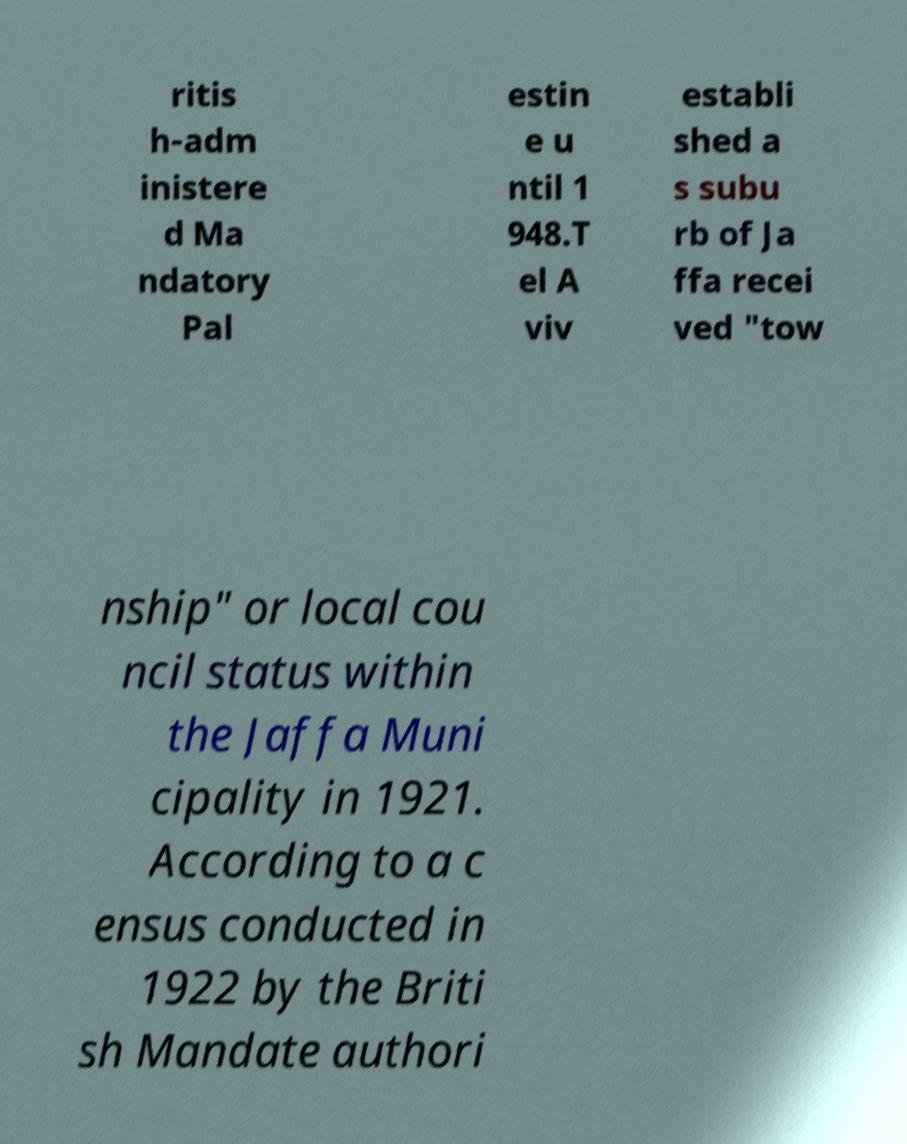Could you extract and type out the text from this image? ritis h-adm inistere d Ma ndatory Pal estin e u ntil 1 948.T el A viv establi shed a s subu rb of Ja ffa recei ved "tow nship" or local cou ncil status within the Jaffa Muni cipality in 1921. According to a c ensus conducted in 1922 by the Briti sh Mandate authori 